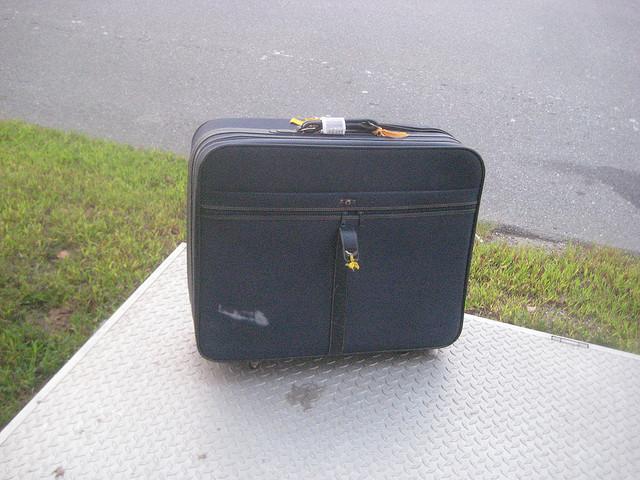Is this a rolling bag?
Quick response, please. Yes. Would a man use this luggage?
Short answer required. Yes. What is this object?
Write a very short answer. Suitcase. Would all the items you need for a trip fit into this suitcase?
Keep it brief. Yes. 